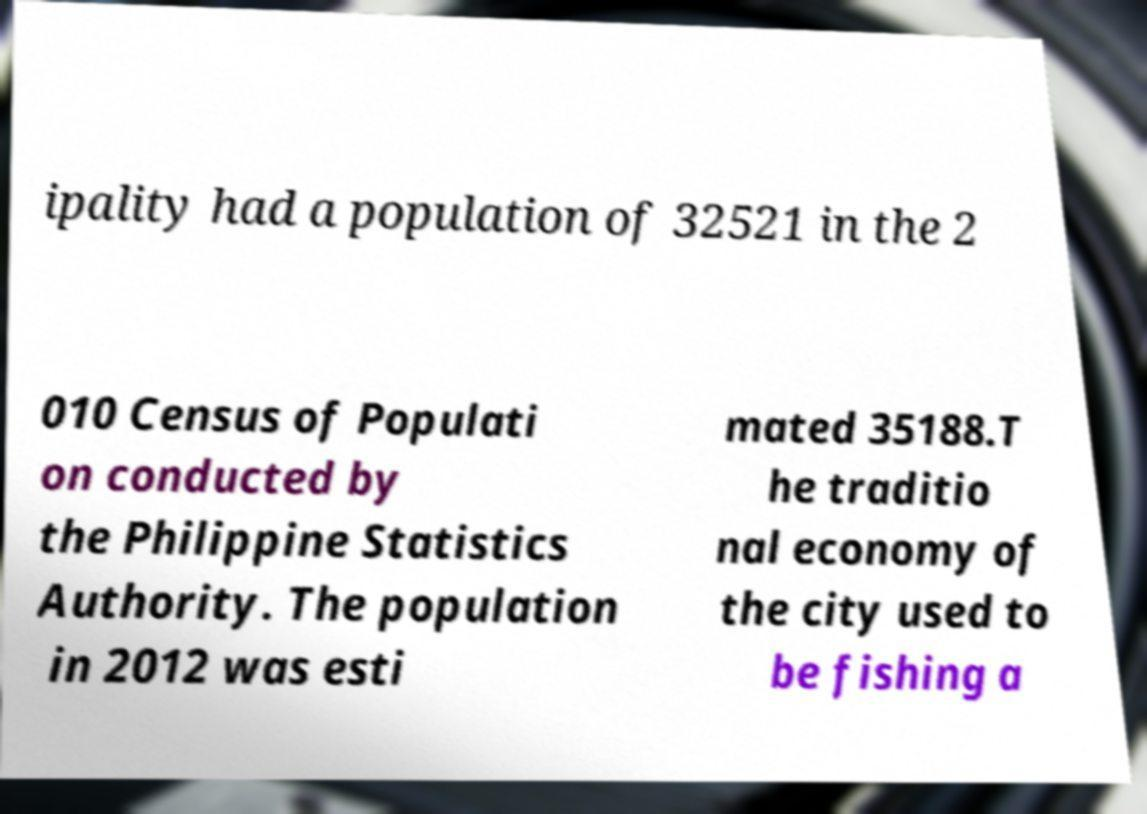I need the written content from this picture converted into text. Can you do that? ipality had a population of 32521 in the 2 010 Census of Populati on conducted by the Philippine Statistics Authority. The population in 2012 was esti mated 35188.T he traditio nal economy of the city used to be fishing a 